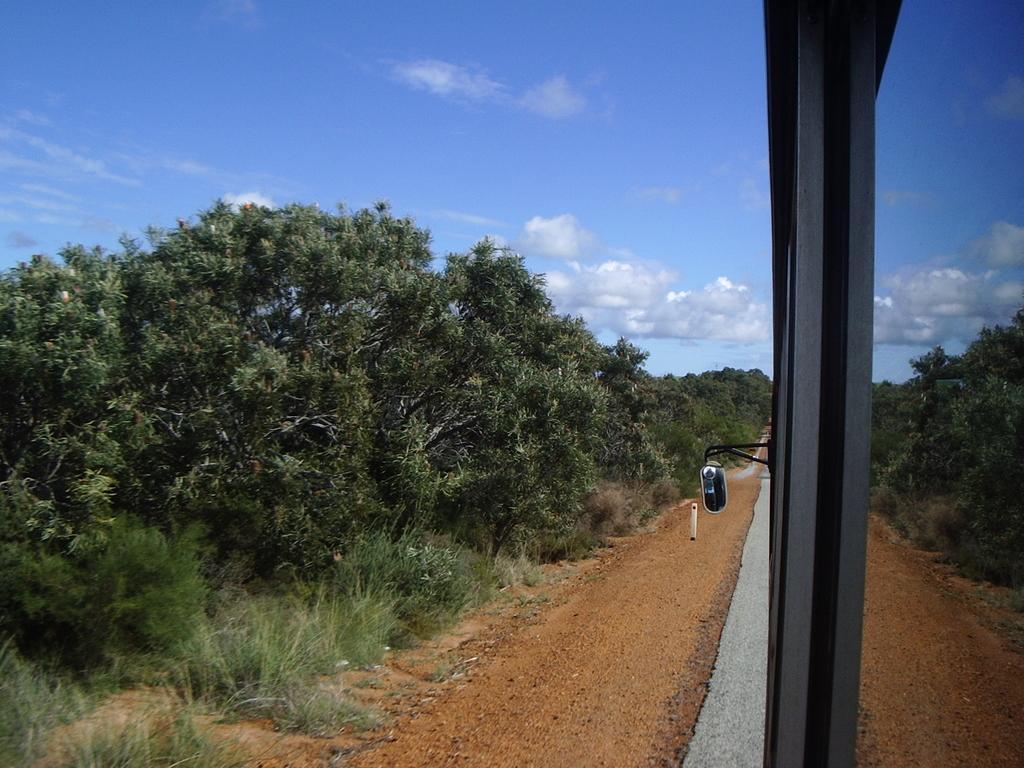Can you describe this image briefly? In this image we can see one vehicle on the road, some small stones near to the road, some trees, bushes, plants and grass on the surface. At the top there is the cloudy sky. 